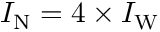Convert formula to latex. <formula><loc_0><loc_0><loc_500><loc_500>I _ { N } = 4 \times I _ { W }</formula> 